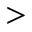<formula> <loc_0><loc_0><loc_500><loc_500>></formula> 